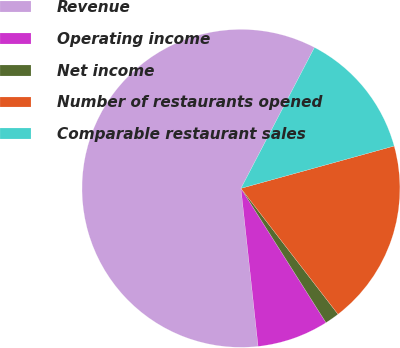Convert chart to OTSL. <chart><loc_0><loc_0><loc_500><loc_500><pie_chart><fcel>Revenue<fcel>Operating income<fcel>Net income<fcel>Number of restaurants opened<fcel>Comparable restaurant sales<nl><fcel>59.37%<fcel>7.26%<fcel>1.47%<fcel>18.84%<fcel>13.05%<nl></chart> 